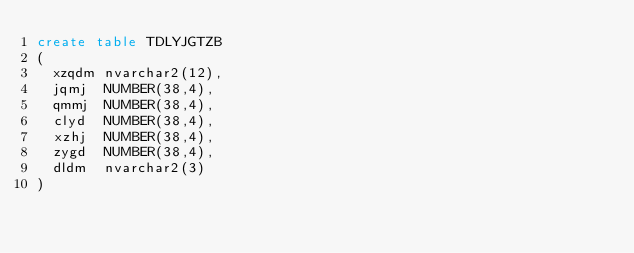Convert code to text. <code><loc_0><loc_0><loc_500><loc_500><_SQL_>create table TDLYJGTZB
(
  xzqdm nvarchar2(12),
  jqmj  NUMBER(38,4),
  qmmj  NUMBER(38,4),
  clyd  NUMBER(38,4),
  xzhj  NUMBER(38,4),
  zygd  NUMBER(38,4),
  dldm  nvarchar2(3)
)
</code> 